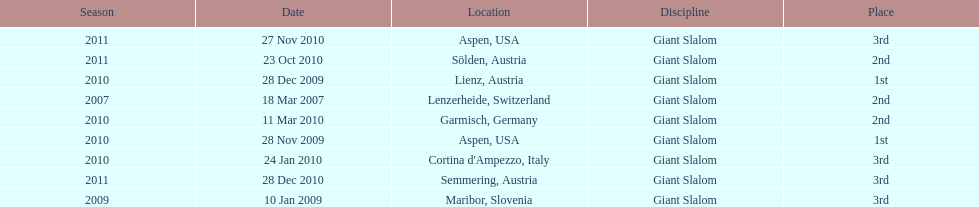The final race finishing place was not 1st but what other place? 3rd. Would you mind parsing the complete table? {'header': ['Season', 'Date', 'Location', 'Discipline', 'Place'], 'rows': [['2011', '27 Nov 2010', 'Aspen, USA', 'Giant Slalom', '3rd'], ['2011', '23 Oct 2010', 'Sölden, Austria', 'Giant Slalom', '2nd'], ['2010', '28 Dec 2009', 'Lienz, Austria', 'Giant Slalom', '1st'], ['2007', '18 Mar 2007', 'Lenzerheide, Switzerland', 'Giant Slalom', '2nd'], ['2010', '11 Mar 2010', 'Garmisch, Germany', 'Giant Slalom', '2nd'], ['2010', '28 Nov 2009', 'Aspen, USA', 'Giant Slalom', '1st'], ['2010', '24 Jan 2010', "Cortina d'Ampezzo, Italy", 'Giant Slalom', '3rd'], ['2011', '28 Dec 2010', 'Semmering, Austria', 'Giant Slalom', '3rd'], ['2009', '10 Jan 2009', 'Maribor, Slovenia', 'Giant Slalom', '3rd']]} 